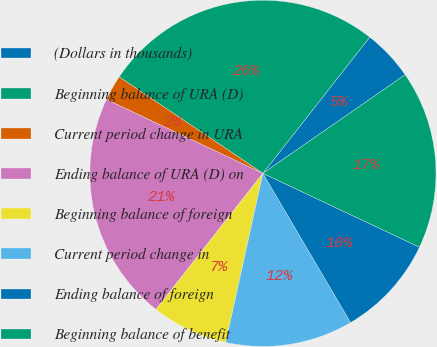<chart> <loc_0><loc_0><loc_500><loc_500><pie_chart><fcel>(Dollars in thousands)<fcel>Beginning balance of URA (D)<fcel>Current period change in URA<fcel>Ending balance of URA (D) on<fcel>Beginning balance of foreign<fcel>Current period change in<fcel>Ending balance of foreign<fcel>Beginning balance of benefit<nl><fcel>4.77%<fcel>26.18%<fcel>2.39%<fcel>21.42%<fcel>7.15%<fcel>11.91%<fcel>9.53%<fcel>16.66%<nl></chart> 